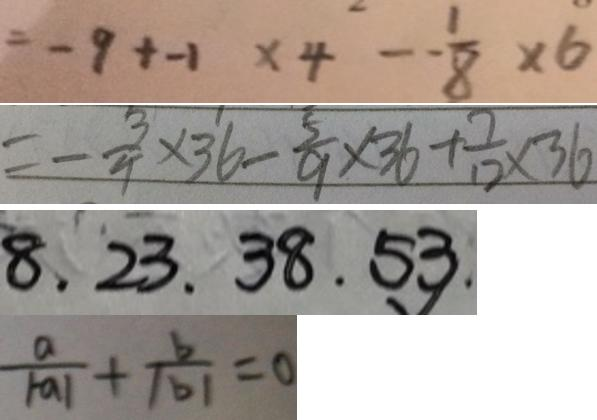<formula> <loc_0><loc_0><loc_500><loc_500>= - 9 + - 1 \times 4 - - \frac { 1 } { 8 } \times 6 
 = - \frac { 3 } { 4 } \times 3 6 - \frac { 5 } { 9 } \times 3 6 + \frac { 7 } { 1 2 } \times 3 6 
 8 . 2 3 . 3 8 . 5 3 . 
 \frac { a } { \vert - a \vert } + \frac { b } { \vert b \vert } = 0</formula> 